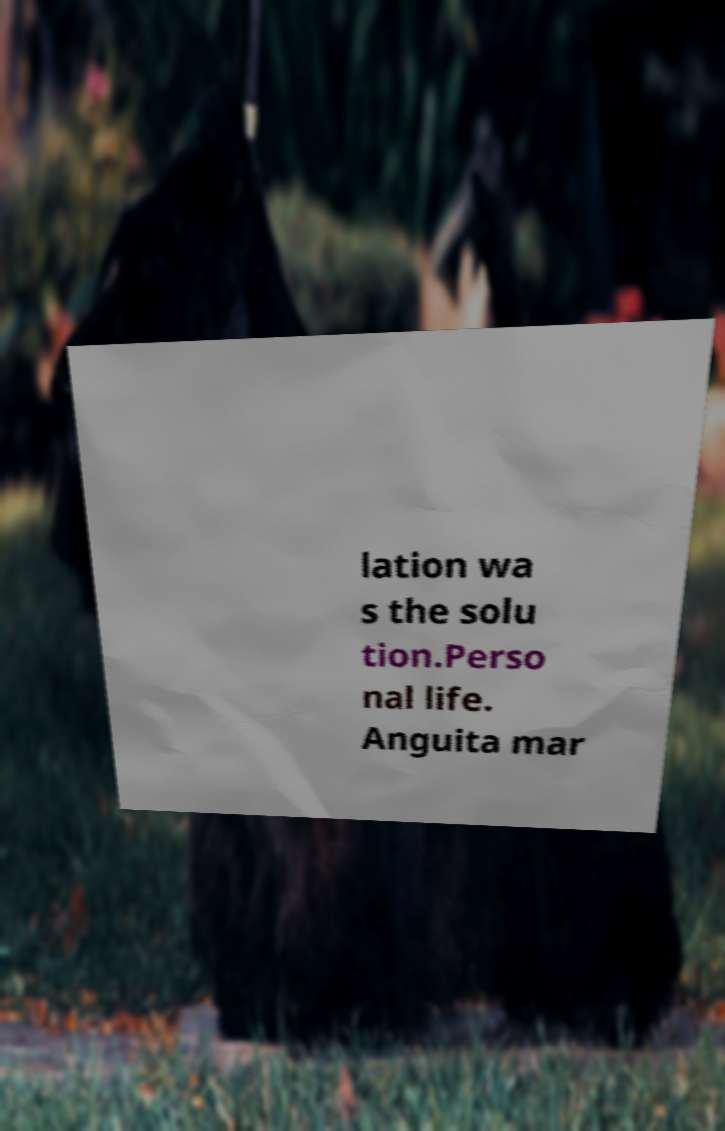I need the written content from this picture converted into text. Can you do that? lation wa s the solu tion.Perso nal life. Anguita mar 